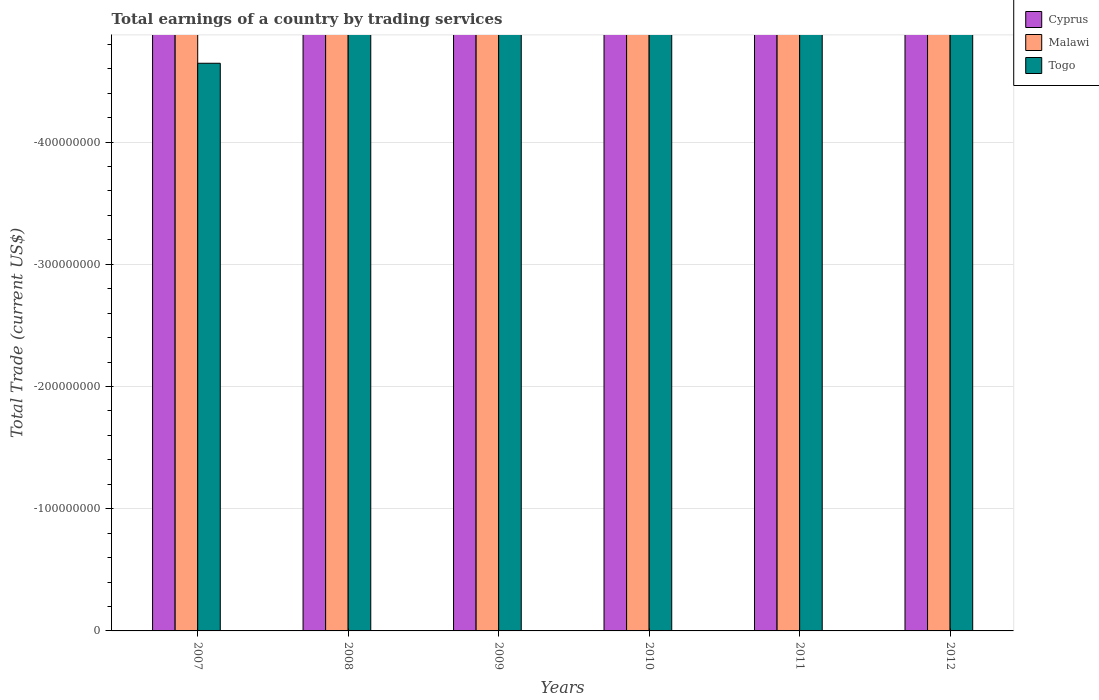How many different coloured bars are there?
Offer a terse response. 0. Are the number of bars per tick equal to the number of legend labels?
Provide a succinct answer. No. Are the number of bars on each tick of the X-axis equal?
Make the answer very short. Yes. How many bars are there on the 2nd tick from the right?
Ensure brevity in your answer.  0. What is the label of the 3rd group of bars from the left?
Keep it short and to the point. 2009. In how many cases, is the number of bars for a given year not equal to the number of legend labels?
Make the answer very short. 6. What is the total earnings in Togo in 2011?
Your response must be concise. 0. What is the total total earnings in Cyprus in the graph?
Ensure brevity in your answer.  0. In how many years, is the total earnings in Togo greater than the average total earnings in Togo taken over all years?
Give a very brief answer. 0. Is it the case that in every year, the sum of the total earnings in Cyprus and total earnings in Togo is greater than the total earnings in Malawi?
Keep it short and to the point. No. How many bars are there?
Give a very brief answer. 0. Does the graph contain any zero values?
Provide a succinct answer. Yes. Does the graph contain grids?
Offer a very short reply. Yes. How many legend labels are there?
Offer a very short reply. 3. How are the legend labels stacked?
Offer a terse response. Vertical. What is the title of the graph?
Ensure brevity in your answer.  Total earnings of a country by trading services. What is the label or title of the Y-axis?
Offer a terse response. Total Trade (current US$). What is the Total Trade (current US$) in Malawi in 2008?
Ensure brevity in your answer.  0. What is the Total Trade (current US$) in Togo in 2008?
Provide a succinct answer. 0. What is the Total Trade (current US$) of Cyprus in 2009?
Provide a succinct answer. 0. What is the Total Trade (current US$) in Togo in 2009?
Your answer should be very brief. 0. What is the Total Trade (current US$) in Cyprus in 2010?
Ensure brevity in your answer.  0. What is the Total Trade (current US$) in Cyprus in 2011?
Your response must be concise. 0. What is the Total Trade (current US$) in Togo in 2011?
Provide a succinct answer. 0. What is the total Total Trade (current US$) in Cyprus in the graph?
Keep it short and to the point. 0. What is the total Total Trade (current US$) in Malawi in the graph?
Ensure brevity in your answer.  0. What is the total Total Trade (current US$) in Togo in the graph?
Your answer should be compact. 0. What is the average Total Trade (current US$) in Malawi per year?
Make the answer very short. 0. What is the average Total Trade (current US$) in Togo per year?
Your answer should be very brief. 0. 